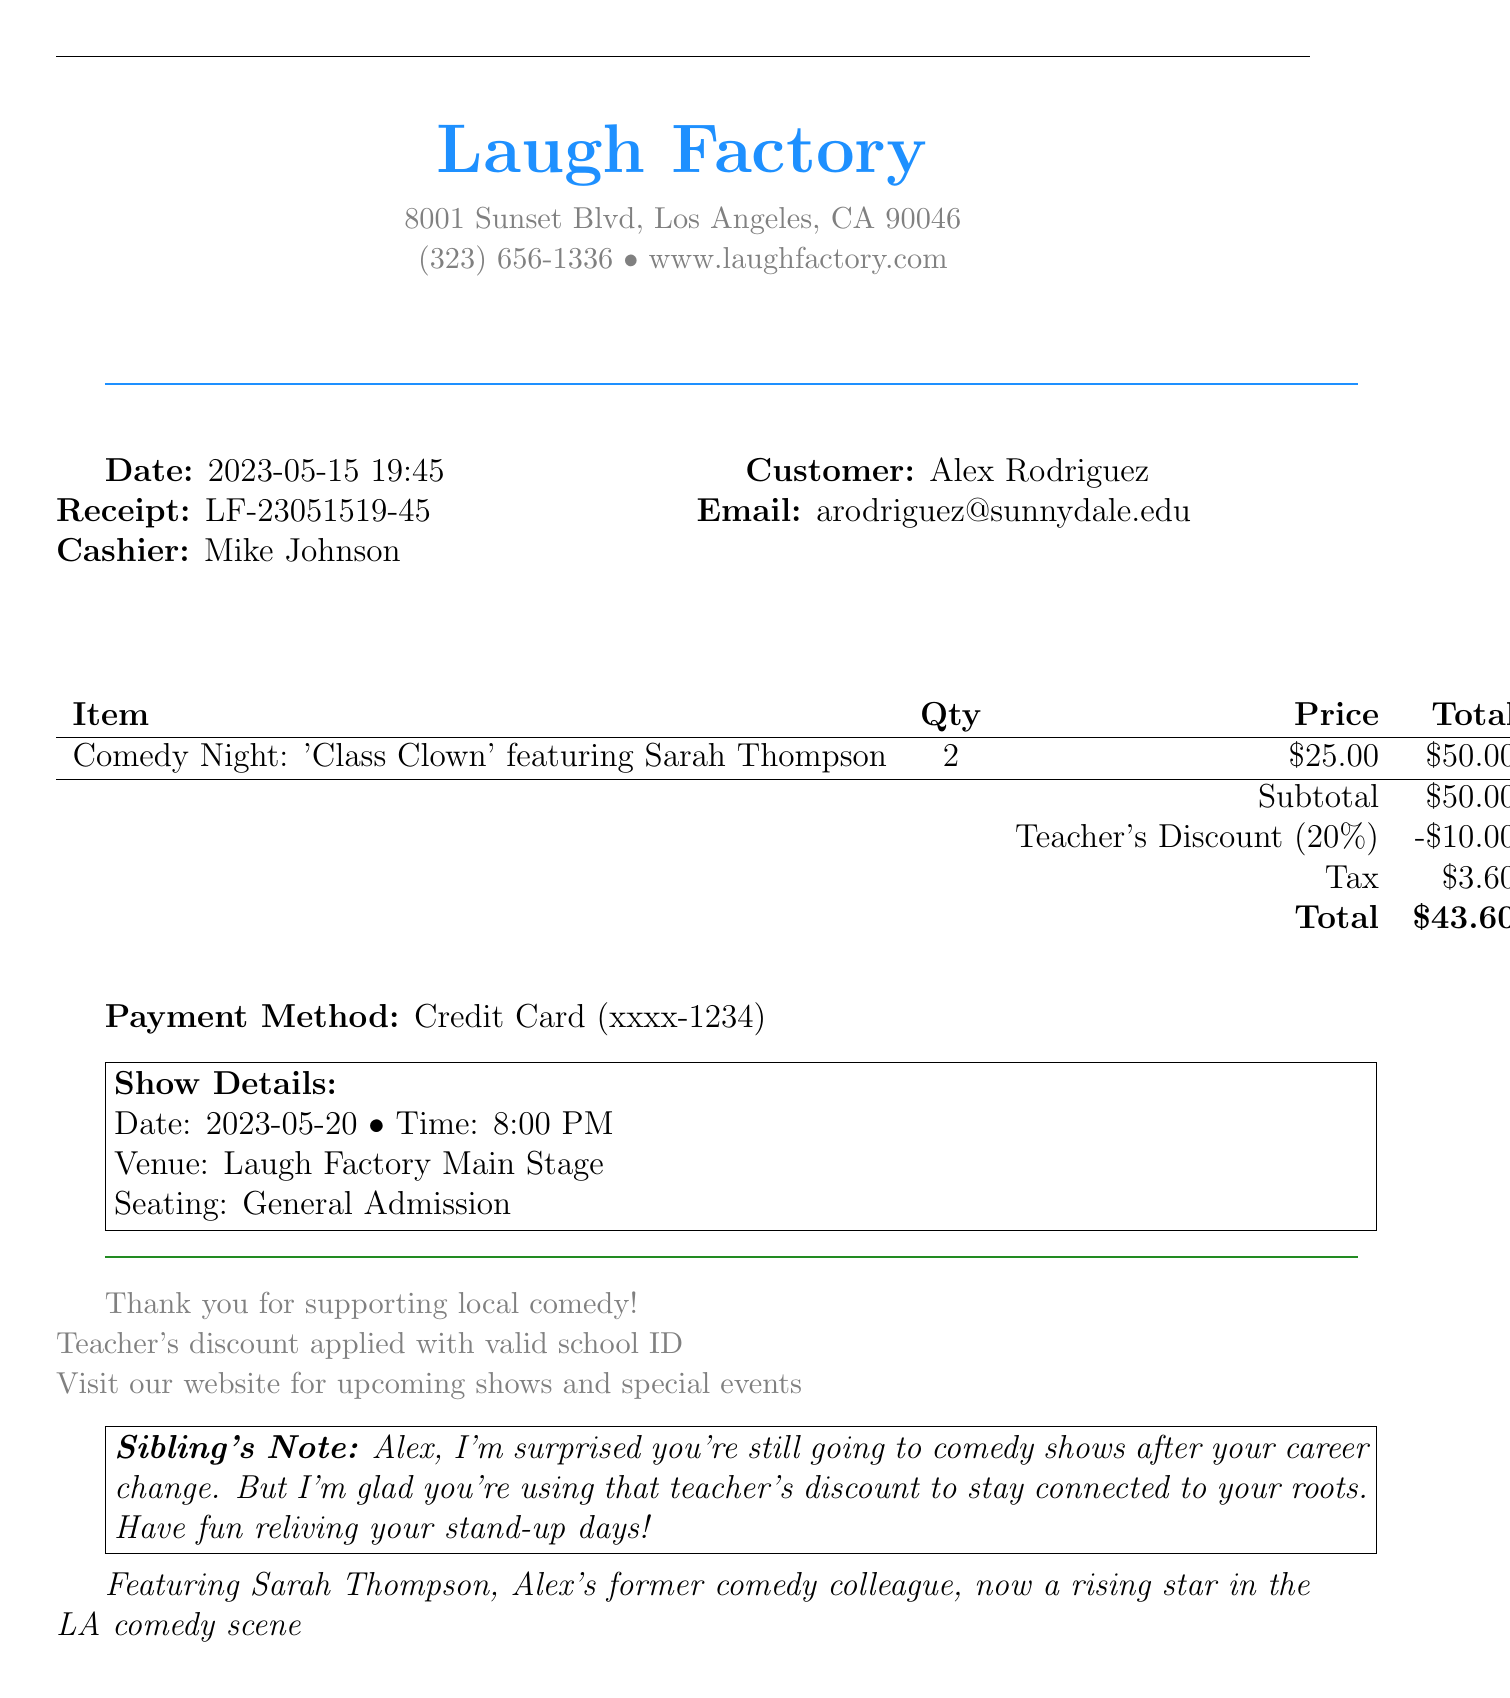What is the name of the comedy show? The name of the comedy show is found in the ticket details section, which is "Comedy Night: 'Class Clown' featuring Sarah Thompson."
Answer: Comedy Night: 'Class Clown' What is the date of the show? The date of the show is specified in the additional info section as 2023-05-20.
Answer: 2023-05-20 What discount was applied? The discount applied is mentioned in the discounts section as "Teacher's Discount (20%)."
Answer: Teacher's Discount (20%) What is the total amount paid? The total amount paid can be found in the pricing section, which lists the total as $43.60.
Answer: $43.60 Who is the cashier? The cashier's name is listed under transaction details and is Mike Johnson.
Answer: Mike Johnson What is the seating type for the show? The seating type is specified in the additional info section as "General Admission."
Answer: General Admission How many tickets were purchased? The quantity of tickets purchased is indicated in the ticket details as 2.
Answer: 2 What is the email of the customer? The customer's email is shown in the customer info section as arodriguez@sunnydale.edu.
Answer: arodriguez@sunnydale.edu What payment method was used? The payment method can be found in the payment method section, which mentions "Credit Card."
Answer: Credit Card 